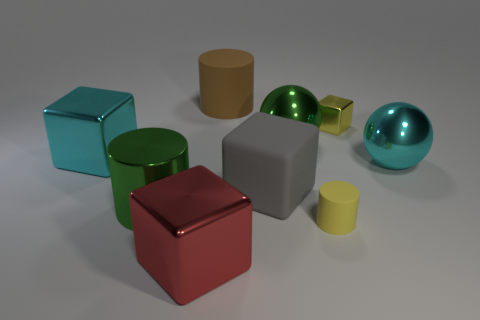Subtract all yellow blocks. How many blocks are left? 3 Subtract all yellow blocks. How many blocks are left? 3 Subtract 1 cylinders. How many cylinders are left? 2 Add 1 matte cylinders. How many objects exist? 10 Subtract all green blocks. Subtract all yellow cylinders. How many blocks are left? 4 Subtract all cylinders. How many objects are left? 6 Add 9 brown rubber objects. How many brown rubber objects exist? 10 Subtract 1 cyan balls. How many objects are left? 8 Subtract all big cyan metal objects. Subtract all large gray rubber cubes. How many objects are left? 6 Add 3 tiny yellow things. How many tiny yellow things are left? 5 